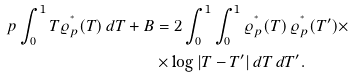Convert formula to latex. <formula><loc_0><loc_0><loc_500><loc_500>p \int _ { 0 } ^ { 1 } T \varrho _ { p } ^ { ^ { * } } ( T ) \, d T + B & = 2 \int _ { 0 } ^ { 1 } \int _ { 0 } ^ { 1 } \varrho _ { p } ^ { ^ { * } } ( T ) \, \varrho _ { p } ^ { ^ { * } } ( T ^ { \prime } ) \times \\ & \times \log | T - T ^ { \prime } | \, d T \, d T ^ { \prime } .</formula> 